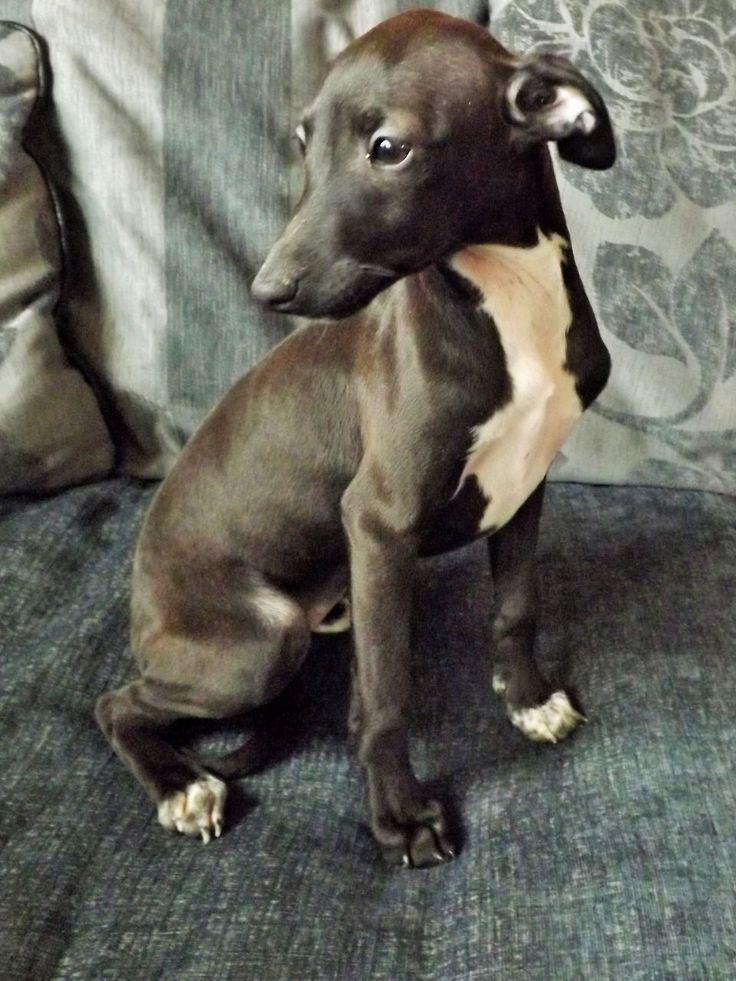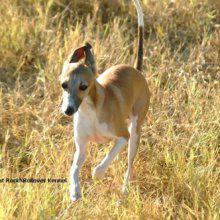The first image is the image on the left, the second image is the image on the right. Considering the images on both sides, is "An image shows a standing dog with its white tail tip curled under and between its legs." valid? Answer yes or no. No. The first image is the image on the left, the second image is the image on the right. Given the left and right images, does the statement "At least one of the dogs is outside on the grass." hold true? Answer yes or no. Yes. 